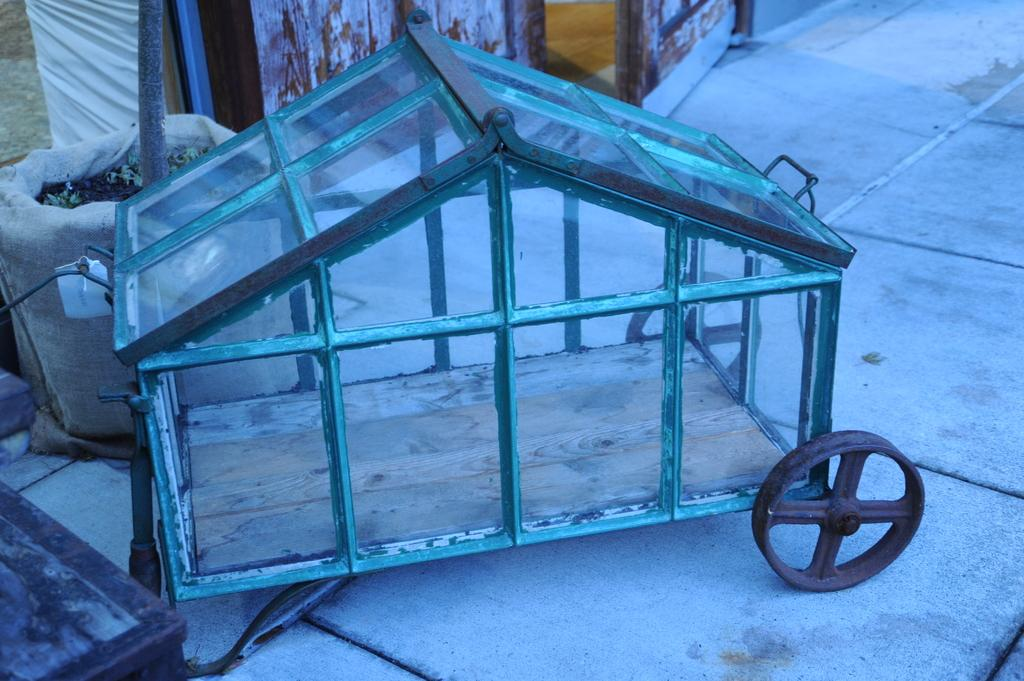What is the main structure visible in the image? There is a glass box in the image. What else can be seen in the image besides the glass box? There is a bag in the image. Can you describe the contents of the bag? The contents of the bag are not specified in the image. What type of ground can be seen beneath the glass box in the image? There is no ground visible beneath the glass box in the image; it appears to be floating or suspended. 